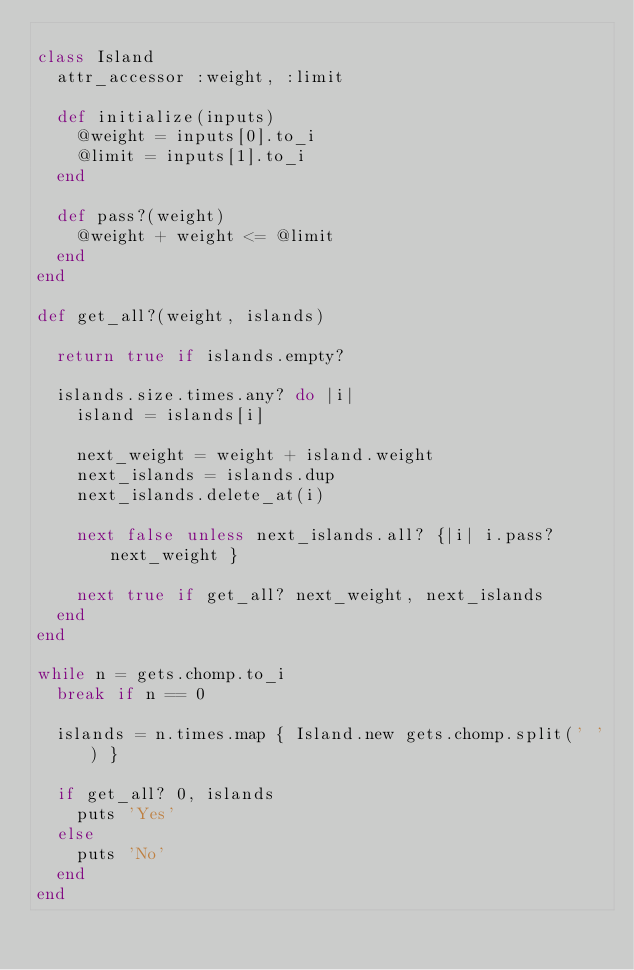<code> <loc_0><loc_0><loc_500><loc_500><_Ruby_>
class Island
  attr_accessor :weight, :limit

  def initialize(inputs)
    @weight = inputs[0].to_i
    @limit = inputs[1].to_i
  end

  def pass?(weight)
    @weight + weight <= @limit
  end
end

def get_all?(weight, islands)

  return true if islands.empty?

  islands.size.times.any? do |i|
    island = islands[i]
    
    next_weight = weight + island.weight
    next_islands = islands.dup
    next_islands.delete_at(i)
    
    next false unless next_islands.all? {|i| i.pass? next_weight }

    next true if get_all? next_weight, next_islands
  end
end

while n = gets.chomp.to_i
  break if n == 0

  islands = n.times.map { Island.new gets.chomp.split(' ') }

  if get_all? 0, islands
    puts 'Yes'
  else
    puts 'No'
  end
end</code> 